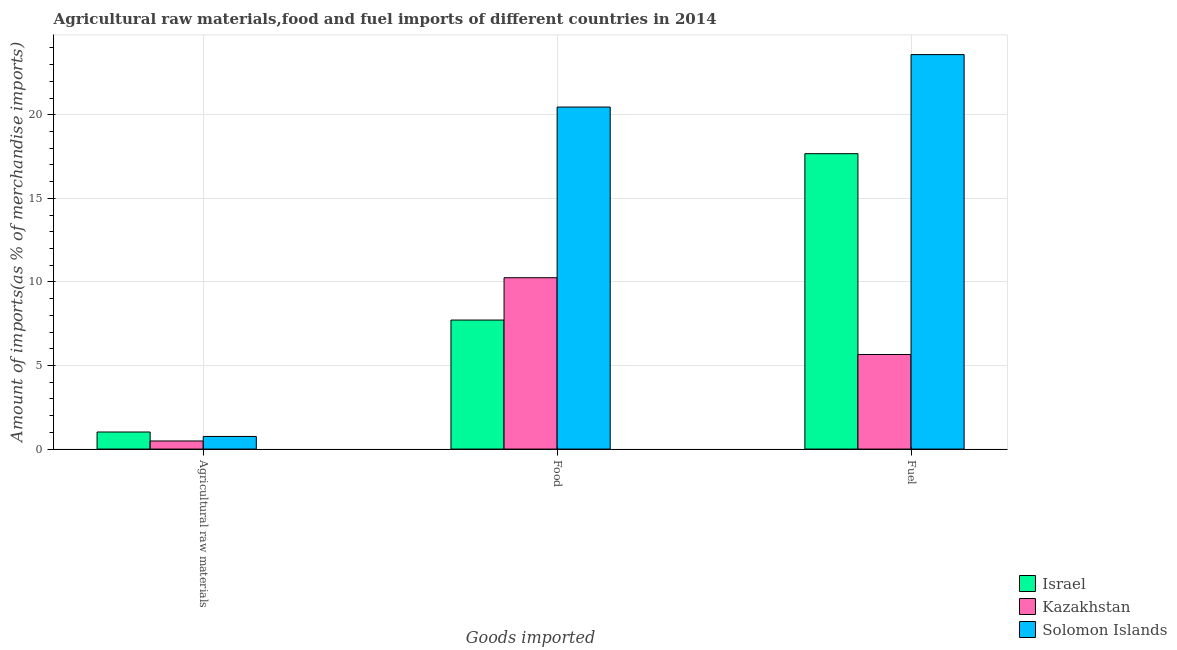Are the number of bars per tick equal to the number of legend labels?
Your answer should be very brief. Yes. Are the number of bars on each tick of the X-axis equal?
Your answer should be very brief. Yes. How many bars are there on the 3rd tick from the right?
Keep it short and to the point. 3. What is the label of the 1st group of bars from the left?
Your response must be concise. Agricultural raw materials. What is the percentage of food imports in Kazakhstan?
Offer a very short reply. 10.25. Across all countries, what is the maximum percentage of raw materials imports?
Offer a terse response. 1.02. Across all countries, what is the minimum percentage of food imports?
Your answer should be compact. 7.72. In which country was the percentage of food imports maximum?
Keep it short and to the point. Solomon Islands. In which country was the percentage of raw materials imports minimum?
Provide a short and direct response. Kazakhstan. What is the total percentage of food imports in the graph?
Your answer should be compact. 38.44. What is the difference between the percentage of food imports in Israel and that in Solomon Islands?
Your answer should be very brief. -12.74. What is the difference between the percentage of fuel imports in Kazakhstan and the percentage of raw materials imports in Solomon Islands?
Offer a very short reply. 4.9. What is the average percentage of fuel imports per country?
Your response must be concise. 15.65. What is the difference between the percentage of fuel imports and percentage of food imports in Kazakhstan?
Your answer should be compact. -4.59. What is the ratio of the percentage of fuel imports in Israel to that in Kazakhstan?
Your response must be concise. 3.12. Is the percentage of fuel imports in Solomon Islands less than that in Israel?
Provide a short and direct response. No. What is the difference between the highest and the second highest percentage of fuel imports?
Keep it short and to the point. 5.93. What is the difference between the highest and the lowest percentage of fuel imports?
Your response must be concise. 17.94. In how many countries, is the percentage of fuel imports greater than the average percentage of fuel imports taken over all countries?
Your answer should be very brief. 2. Is the sum of the percentage of fuel imports in Israel and Kazakhstan greater than the maximum percentage of raw materials imports across all countries?
Keep it short and to the point. Yes. What does the 1st bar from the right in Food represents?
Offer a very short reply. Solomon Islands. Is it the case that in every country, the sum of the percentage of raw materials imports and percentage of food imports is greater than the percentage of fuel imports?
Keep it short and to the point. No. How many bars are there?
Offer a very short reply. 9. Are all the bars in the graph horizontal?
Your answer should be compact. No. Does the graph contain any zero values?
Make the answer very short. No. Does the graph contain grids?
Ensure brevity in your answer.  Yes. What is the title of the graph?
Your answer should be very brief. Agricultural raw materials,food and fuel imports of different countries in 2014. Does "Pacific island small states" appear as one of the legend labels in the graph?
Provide a short and direct response. No. What is the label or title of the X-axis?
Keep it short and to the point. Goods imported. What is the label or title of the Y-axis?
Give a very brief answer. Amount of imports(as % of merchandise imports). What is the Amount of imports(as % of merchandise imports) in Israel in Agricultural raw materials?
Provide a short and direct response. 1.02. What is the Amount of imports(as % of merchandise imports) in Kazakhstan in Agricultural raw materials?
Make the answer very short. 0.48. What is the Amount of imports(as % of merchandise imports) of Solomon Islands in Agricultural raw materials?
Make the answer very short. 0.76. What is the Amount of imports(as % of merchandise imports) of Israel in Food?
Keep it short and to the point. 7.72. What is the Amount of imports(as % of merchandise imports) of Kazakhstan in Food?
Your answer should be very brief. 10.25. What is the Amount of imports(as % of merchandise imports) of Solomon Islands in Food?
Give a very brief answer. 20.46. What is the Amount of imports(as % of merchandise imports) in Israel in Fuel?
Give a very brief answer. 17.67. What is the Amount of imports(as % of merchandise imports) of Kazakhstan in Fuel?
Provide a succinct answer. 5.66. What is the Amount of imports(as % of merchandise imports) in Solomon Islands in Fuel?
Provide a succinct answer. 23.6. Across all Goods imported, what is the maximum Amount of imports(as % of merchandise imports) in Israel?
Offer a terse response. 17.67. Across all Goods imported, what is the maximum Amount of imports(as % of merchandise imports) of Kazakhstan?
Your answer should be compact. 10.25. Across all Goods imported, what is the maximum Amount of imports(as % of merchandise imports) of Solomon Islands?
Offer a very short reply. 23.6. Across all Goods imported, what is the minimum Amount of imports(as % of merchandise imports) in Israel?
Your answer should be compact. 1.02. Across all Goods imported, what is the minimum Amount of imports(as % of merchandise imports) in Kazakhstan?
Ensure brevity in your answer.  0.48. Across all Goods imported, what is the minimum Amount of imports(as % of merchandise imports) of Solomon Islands?
Your answer should be very brief. 0.76. What is the total Amount of imports(as % of merchandise imports) of Israel in the graph?
Make the answer very short. 26.41. What is the total Amount of imports(as % of merchandise imports) in Kazakhstan in the graph?
Offer a very short reply. 16.39. What is the total Amount of imports(as % of merchandise imports) of Solomon Islands in the graph?
Your answer should be very brief. 44.82. What is the difference between the Amount of imports(as % of merchandise imports) in Israel in Agricultural raw materials and that in Food?
Make the answer very short. -6.7. What is the difference between the Amount of imports(as % of merchandise imports) of Kazakhstan in Agricultural raw materials and that in Food?
Provide a short and direct response. -9.77. What is the difference between the Amount of imports(as % of merchandise imports) in Solomon Islands in Agricultural raw materials and that in Food?
Provide a succinct answer. -19.71. What is the difference between the Amount of imports(as % of merchandise imports) of Israel in Agricultural raw materials and that in Fuel?
Your response must be concise. -16.65. What is the difference between the Amount of imports(as % of merchandise imports) in Kazakhstan in Agricultural raw materials and that in Fuel?
Make the answer very short. -5.17. What is the difference between the Amount of imports(as % of merchandise imports) in Solomon Islands in Agricultural raw materials and that in Fuel?
Give a very brief answer. -22.85. What is the difference between the Amount of imports(as % of merchandise imports) in Israel in Food and that in Fuel?
Your response must be concise. -9.96. What is the difference between the Amount of imports(as % of merchandise imports) of Kazakhstan in Food and that in Fuel?
Your answer should be very brief. 4.59. What is the difference between the Amount of imports(as % of merchandise imports) in Solomon Islands in Food and that in Fuel?
Ensure brevity in your answer.  -3.14. What is the difference between the Amount of imports(as % of merchandise imports) in Israel in Agricultural raw materials and the Amount of imports(as % of merchandise imports) in Kazakhstan in Food?
Ensure brevity in your answer.  -9.23. What is the difference between the Amount of imports(as % of merchandise imports) of Israel in Agricultural raw materials and the Amount of imports(as % of merchandise imports) of Solomon Islands in Food?
Ensure brevity in your answer.  -19.44. What is the difference between the Amount of imports(as % of merchandise imports) of Kazakhstan in Agricultural raw materials and the Amount of imports(as % of merchandise imports) of Solomon Islands in Food?
Offer a terse response. -19.98. What is the difference between the Amount of imports(as % of merchandise imports) in Israel in Agricultural raw materials and the Amount of imports(as % of merchandise imports) in Kazakhstan in Fuel?
Your response must be concise. -4.64. What is the difference between the Amount of imports(as % of merchandise imports) of Israel in Agricultural raw materials and the Amount of imports(as % of merchandise imports) of Solomon Islands in Fuel?
Provide a succinct answer. -22.58. What is the difference between the Amount of imports(as % of merchandise imports) in Kazakhstan in Agricultural raw materials and the Amount of imports(as % of merchandise imports) in Solomon Islands in Fuel?
Offer a terse response. -23.12. What is the difference between the Amount of imports(as % of merchandise imports) of Israel in Food and the Amount of imports(as % of merchandise imports) of Kazakhstan in Fuel?
Your answer should be very brief. 2.06. What is the difference between the Amount of imports(as % of merchandise imports) of Israel in Food and the Amount of imports(as % of merchandise imports) of Solomon Islands in Fuel?
Your answer should be very brief. -15.88. What is the difference between the Amount of imports(as % of merchandise imports) in Kazakhstan in Food and the Amount of imports(as % of merchandise imports) in Solomon Islands in Fuel?
Keep it short and to the point. -13.35. What is the average Amount of imports(as % of merchandise imports) in Israel per Goods imported?
Make the answer very short. 8.8. What is the average Amount of imports(as % of merchandise imports) in Kazakhstan per Goods imported?
Your answer should be very brief. 5.46. What is the average Amount of imports(as % of merchandise imports) of Solomon Islands per Goods imported?
Ensure brevity in your answer.  14.94. What is the difference between the Amount of imports(as % of merchandise imports) of Israel and Amount of imports(as % of merchandise imports) of Kazakhstan in Agricultural raw materials?
Offer a terse response. 0.54. What is the difference between the Amount of imports(as % of merchandise imports) in Israel and Amount of imports(as % of merchandise imports) in Solomon Islands in Agricultural raw materials?
Offer a very short reply. 0.27. What is the difference between the Amount of imports(as % of merchandise imports) of Kazakhstan and Amount of imports(as % of merchandise imports) of Solomon Islands in Agricultural raw materials?
Ensure brevity in your answer.  -0.27. What is the difference between the Amount of imports(as % of merchandise imports) of Israel and Amount of imports(as % of merchandise imports) of Kazakhstan in Food?
Your response must be concise. -2.53. What is the difference between the Amount of imports(as % of merchandise imports) in Israel and Amount of imports(as % of merchandise imports) in Solomon Islands in Food?
Provide a short and direct response. -12.74. What is the difference between the Amount of imports(as % of merchandise imports) of Kazakhstan and Amount of imports(as % of merchandise imports) of Solomon Islands in Food?
Keep it short and to the point. -10.21. What is the difference between the Amount of imports(as % of merchandise imports) in Israel and Amount of imports(as % of merchandise imports) in Kazakhstan in Fuel?
Give a very brief answer. 12.02. What is the difference between the Amount of imports(as % of merchandise imports) in Israel and Amount of imports(as % of merchandise imports) in Solomon Islands in Fuel?
Your answer should be very brief. -5.93. What is the difference between the Amount of imports(as % of merchandise imports) in Kazakhstan and Amount of imports(as % of merchandise imports) in Solomon Islands in Fuel?
Provide a succinct answer. -17.94. What is the ratio of the Amount of imports(as % of merchandise imports) in Israel in Agricultural raw materials to that in Food?
Offer a very short reply. 0.13. What is the ratio of the Amount of imports(as % of merchandise imports) in Kazakhstan in Agricultural raw materials to that in Food?
Your response must be concise. 0.05. What is the ratio of the Amount of imports(as % of merchandise imports) in Solomon Islands in Agricultural raw materials to that in Food?
Your answer should be very brief. 0.04. What is the ratio of the Amount of imports(as % of merchandise imports) in Israel in Agricultural raw materials to that in Fuel?
Your response must be concise. 0.06. What is the ratio of the Amount of imports(as % of merchandise imports) in Kazakhstan in Agricultural raw materials to that in Fuel?
Your answer should be very brief. 0.09. What is the ratio of the Amount of imports(as % of merchandise imports) in Solomon Islands in Agricultural raw materials to that in Fuel?
Offer a very short reply. 0.03. What is the ratio of the Amount of imports(as % of merchandise imports) of Israel in Food to that in Fuel?
Offer a terse response. 0.44. What is the ratio of the Amount of imports(as % of merchandise imports) in Kazakhstan in Food to that in Fuel?
Ensure brevity in your answer.  1.81. What is the ratio of the Amount of imports(as % of merchandise imports) of Solomon Islands in Food to that in Fuel?
Keep it short and to the point. 0.87. What is the difference between the highest and the second highest Amount of imports(as % of merchandise imports) in Israel?
Give a very brief answer. 9.96. What is the difference between the highest and the second highest Amount of imports(as % of merchandise imports) in Kazakhstan?
Your answer should be very brief. 4.59. What is the difference between the highest and the second highest Amount of imports(as % of merchandise imports) of Solomon Islands?
Your answer should be very brief. 3.14. What is the difference between the highest and the lowest Amount of imports(as % of merchandise imports) in Israel?
Give a very brief answer. 16.65. What is the difference between the highest and the lowest Amount of imports(as % of merchandise imports) in Kazakhstan?
Provide a succinct answer. 9.77. What is the difference between the highest and the lowest Amount of imports(as % of merchandise imports) in Solomon Islands?
Make the answer very short. 22.85. 